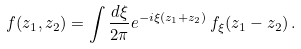Convert formula to latex. <formula><loc_0><loc_0><loc_500><loc_500>f ( z _ { 1 } , z _ { 2 } ) = \int \frac { d \xi } { 2 \pi } e ^ { - i \xi ( z _ { 1 } + z _ { 2 } ) } \, f _ { \xi } ( z _ { 1 } - z _ { 2 } ) \, .</formula> 